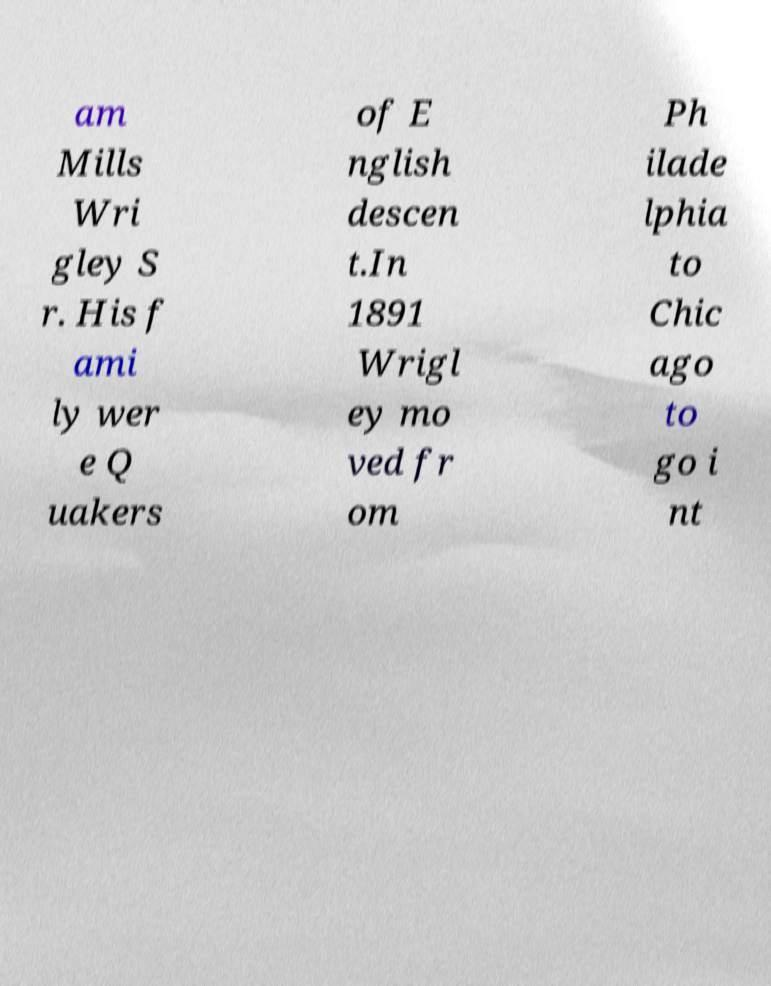For documentation purposes, I need the text within this image transcribed. Could you provide that? am Mills Wri gley S r. His f ami ly wer e Q uakers of E nglish descen t.In 1891 Wrigl ey mo ved fr om Ph ilade lphia to Chic ago to go i nt 